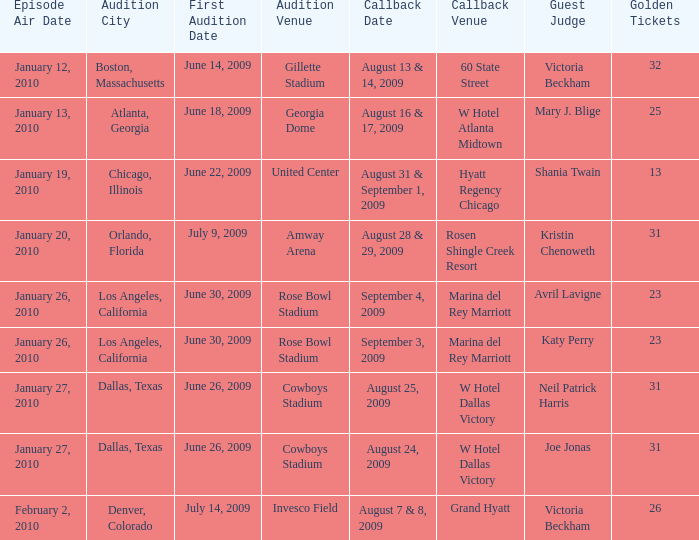In which city is the audition for hyatt regency chicago located? Chicago, Illinois. 